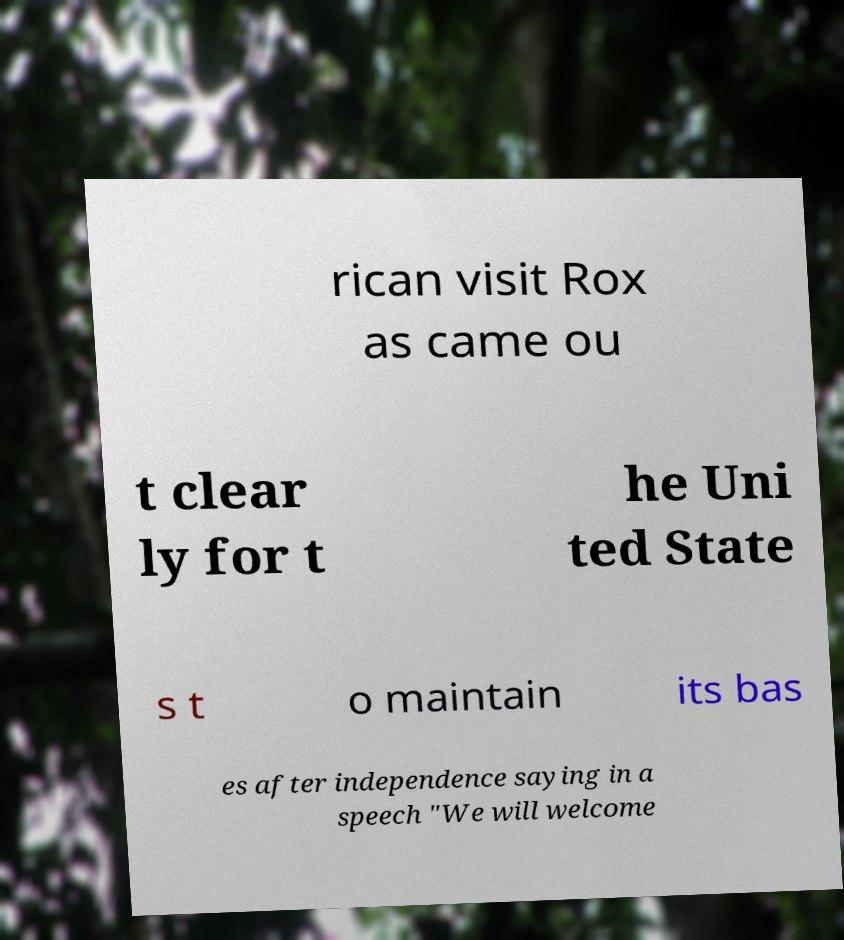What messages or text are displayed in this image? I need them in a readable, typed format. rican visit Rox as came ou t clear ly for t he Uni ted State s t o maintain its bas es after independence saying in a speech "We will welcome 